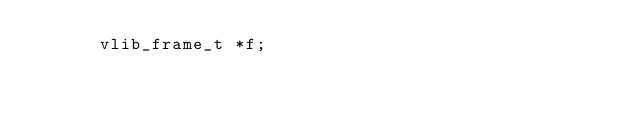<code> <loc_0><loc_0><loc_500><loc_500><_C_>      vlib_frame_t *f;</code> 